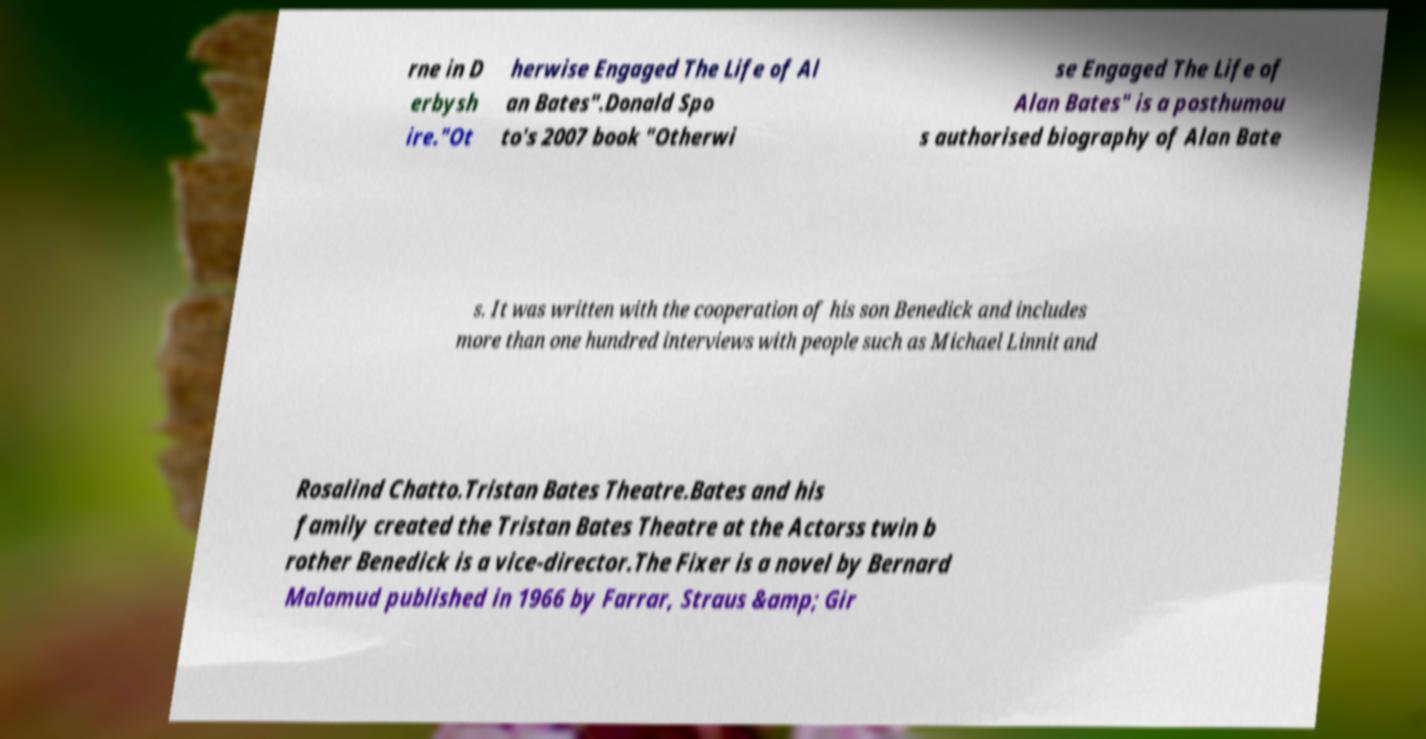Can you accurately transcribe the text from the provided image for me? rne in D erbysh ire."Ot herwise Engaged The Life of Al an Bates".Donald Spo to's 2007 book "Otherwi se Engaged The Life of Alan Bates" is a posthumou s authorised biography of Alan Bate s. It was written with the cooperation of his son Benedick and includes more than one hundred interviews with people such as Michael Linnit and Rosalind Chatto.Tristan Bates Theatre.Bates and his family created the Tristan Bates Theatre at the Actorss twin b rother Benedick is a vice-director.The Fixer is a novel by Bernard Malamud published in 1966 by Farrar, Straus &amp; Gir 